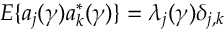<formula> <loc_0><loc_0><loc_500><loc_500>E \{ a _ { j } ( \gamma ) a _ { k } ^ { * } ( \gamma ) \} = \lambda _ { j } ( \gamma ) \delta _ { j , k }</formula> 